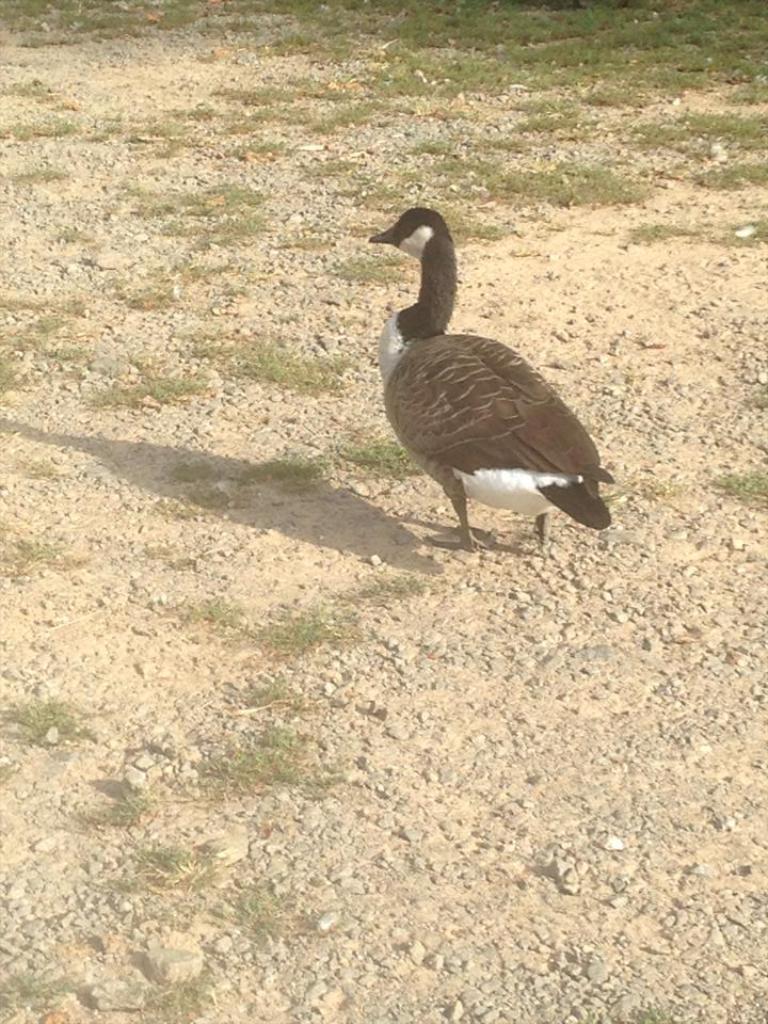In one or two sentences, can you explain what this image depicts? In this image there is a Canada goose bird standing on the surface, in front of the bird there is grass. 